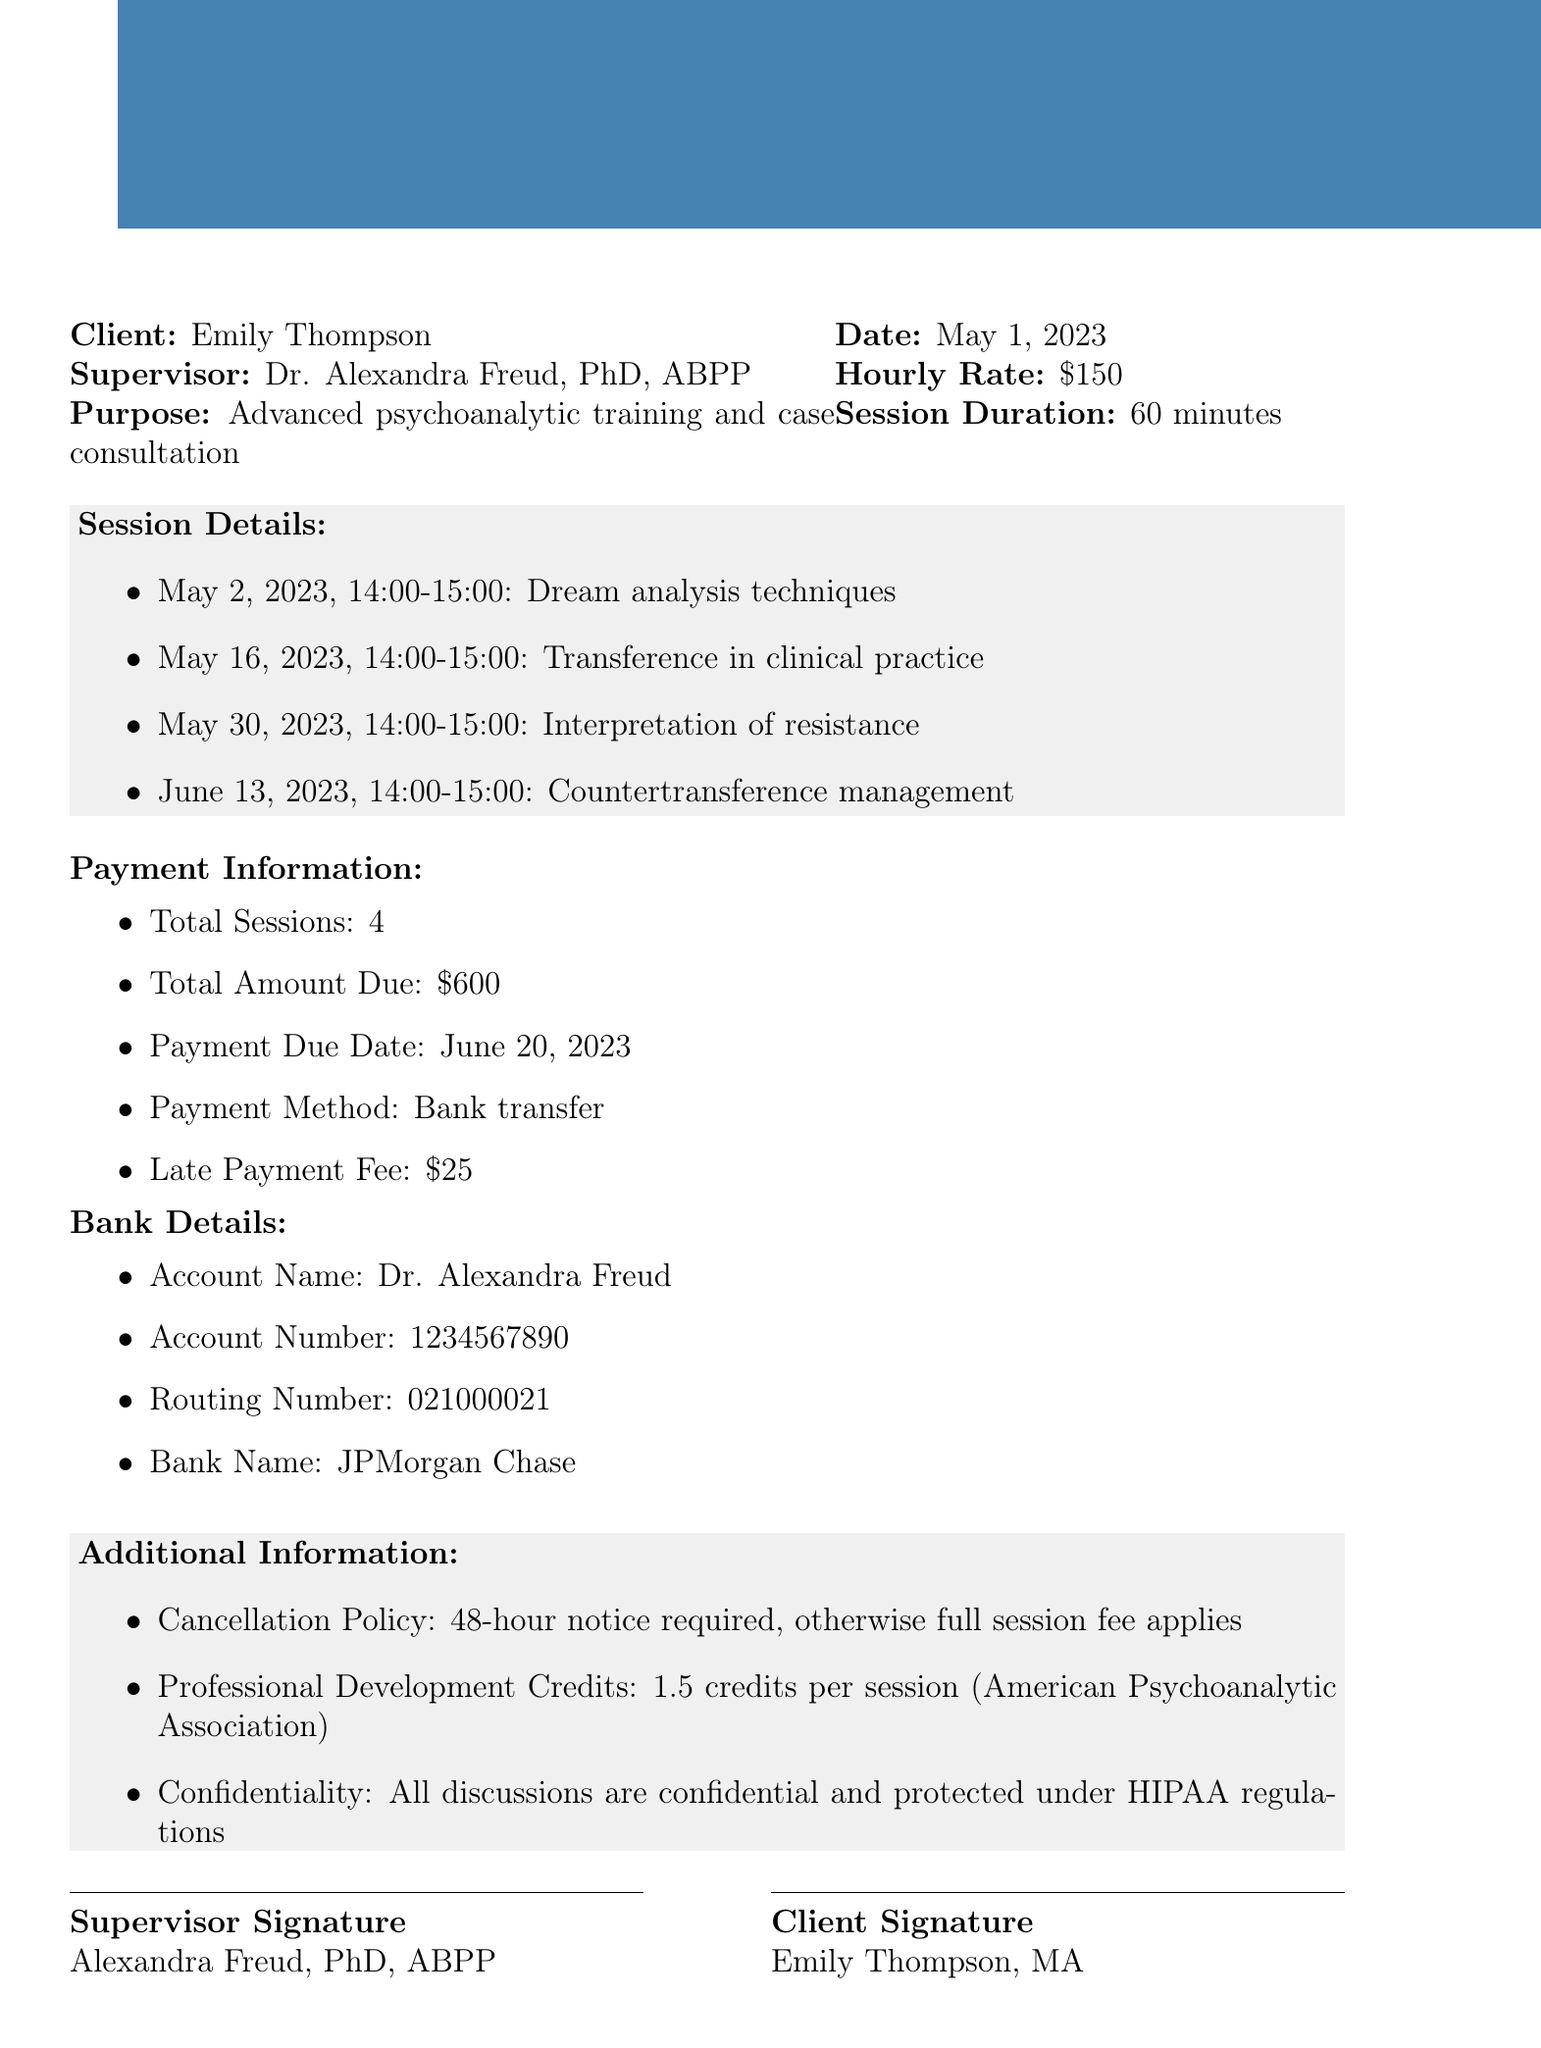what is the client's name? The client's name is explicitly mentioned in the document as Emily Thompson.
Answer: Emily Thompson who is the supervisor? The document states that the supervisor is Dr. Alexandra Freud, who has specific credentials.
Answer: Dr. Alexandra Freud what is the hourly rate for supervision? The document specifies the hourly rate for supervision sessions.
Answer: $150 how many sessions are documented? The total number of sessions is listed in the document as part of the payment information.
Answer: 4 what is the total amount due? The total amount due is outlined in the payment information section of the document.
Answer: $600 when is the payment due date? The date by which payment must be made is provided in the document.
Answer: June 20, 2023 what is the cancellation policy? The cancellation policy details are noted in the additional information section of the document.
Answer: 48-hour notice required, otherwise full session fee applies how many professional development credits can be earned per session? The document lists the number of professional development credits awarded per session.
Answer: 1.5 credits what is the focus of the first session? The document provides details about the focus of each session, starting with the first.
Answer: Dream analysis techniques 